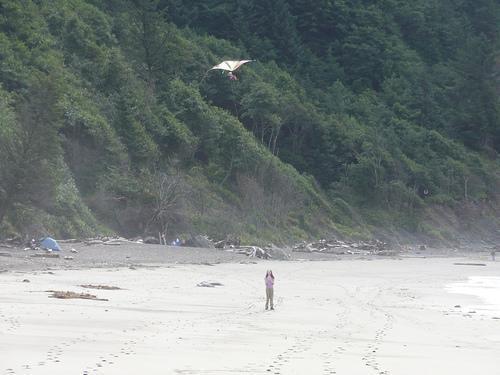How many people are there in this picture?
Give a very brief answer. 1. 